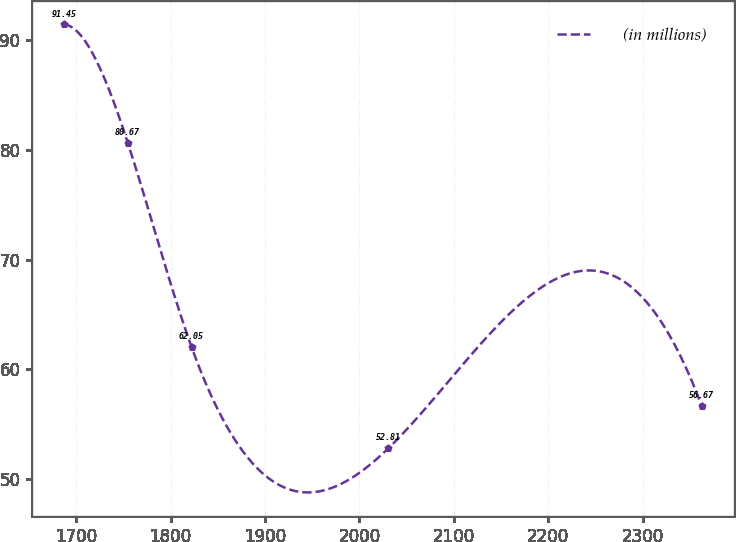Convert chart to OTSL. <chart><loc_0><loc_0><loc_500><loc_500><line_chart><ecel><fcel>(in millions)<nl><fcel>1687.05<fcel>91.45<nl><fcel>1754.61<fcel>80.67<nl><fcel>1822.17<fcel>62.05<nl><fcel>2030.82<fcel>52.81<nl><fcel>2362.69<fcel>56.67<nl></chart> 